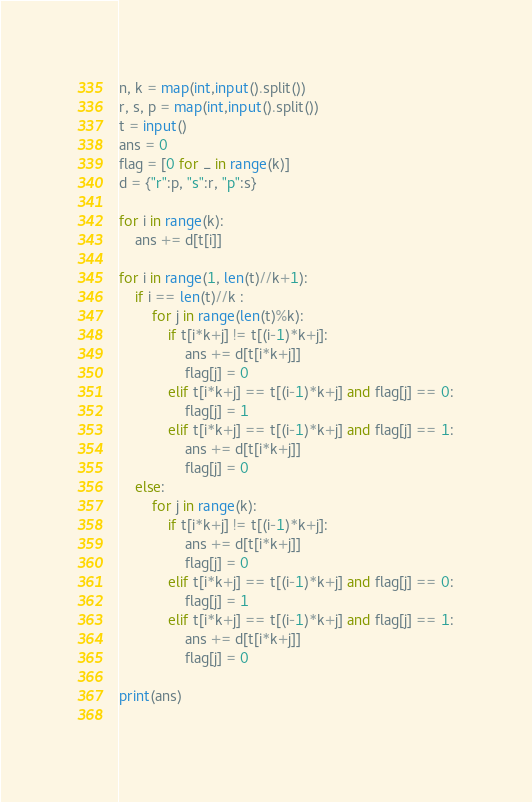Convert code to text. <code><loc_0><loc_0><loc_500><loc_500><_Python_>n, k = map(int,input().split())
r, s, p = map(int,input().split())
t = input()
ans = 0
flag = [0 for _ in range(k)]
d = {"r":p, "s":r, "p":s}

for i in range(k):
    ans += d[t[i]]

for i in range(1, len(t)//k+1):
    if i == len(t)//k :
        for j in range(len(t)%k):
            if t[i*k+j] != t[(i-1)*k+j]:
                ans += d[t[i*k+j]]
                flag[j] = 0
            elif t[i*k+j] == t[(i-1)*k+j] and flag[j] == 0:
                flag[j] = 1
            elif t[i*k+j] == t[(i-1)*k+j] and flag[j] == 1:
                ans += d[t[i*k+j]]
                flag[j] = 0
    else:
        for j in range(k):
            if t[i*k+j] != t[(i-1)*k+j]:
                ans += d[t[i*k+j]]
                flag[j] = 0
            elif t[i*k+j] == t[(i-1)*k+j] and flag[j] == 0:
                flag[j] = 1
            elif t[i*k+j] == t[(i-1)*k+j] and flag[j] == 1:
                ans += d[t[i*k+j]]
                flag[j] = 0

print(ans)
 </code> 